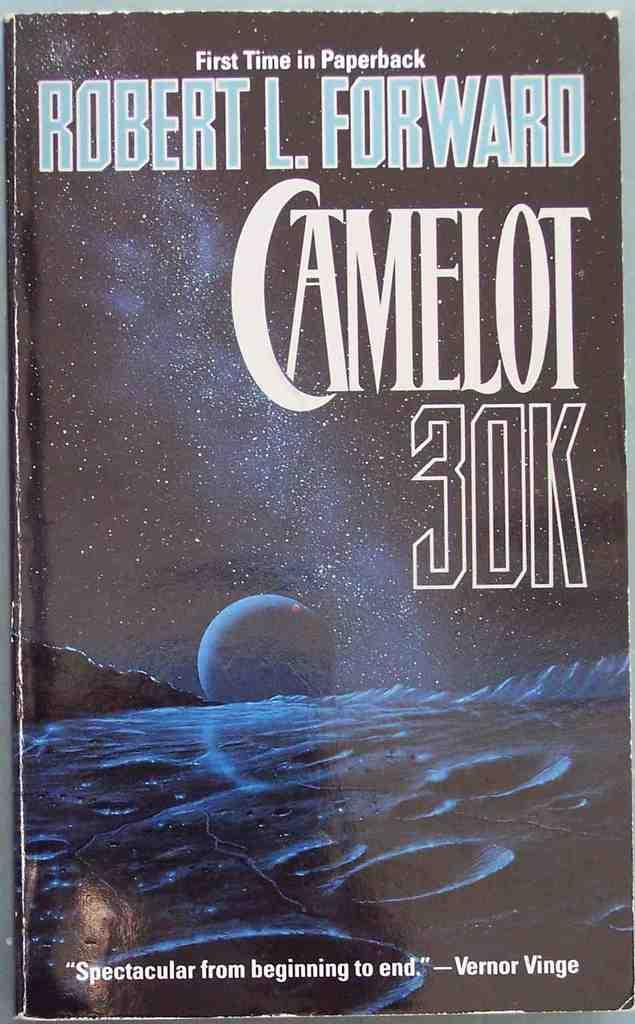<image>
Offer a succinct explanation of the picture presented. A book by Robert LForward, tittled Camelot 30k 